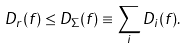Convert formula to latex. <formula><loc_0><loc_0><loc_500><loc_500>D _ { r } ( f ) \leq D _ { \Sigma } ( f ) \equiv \sum _ { i } D _ { i } ( f ) .</formula> 